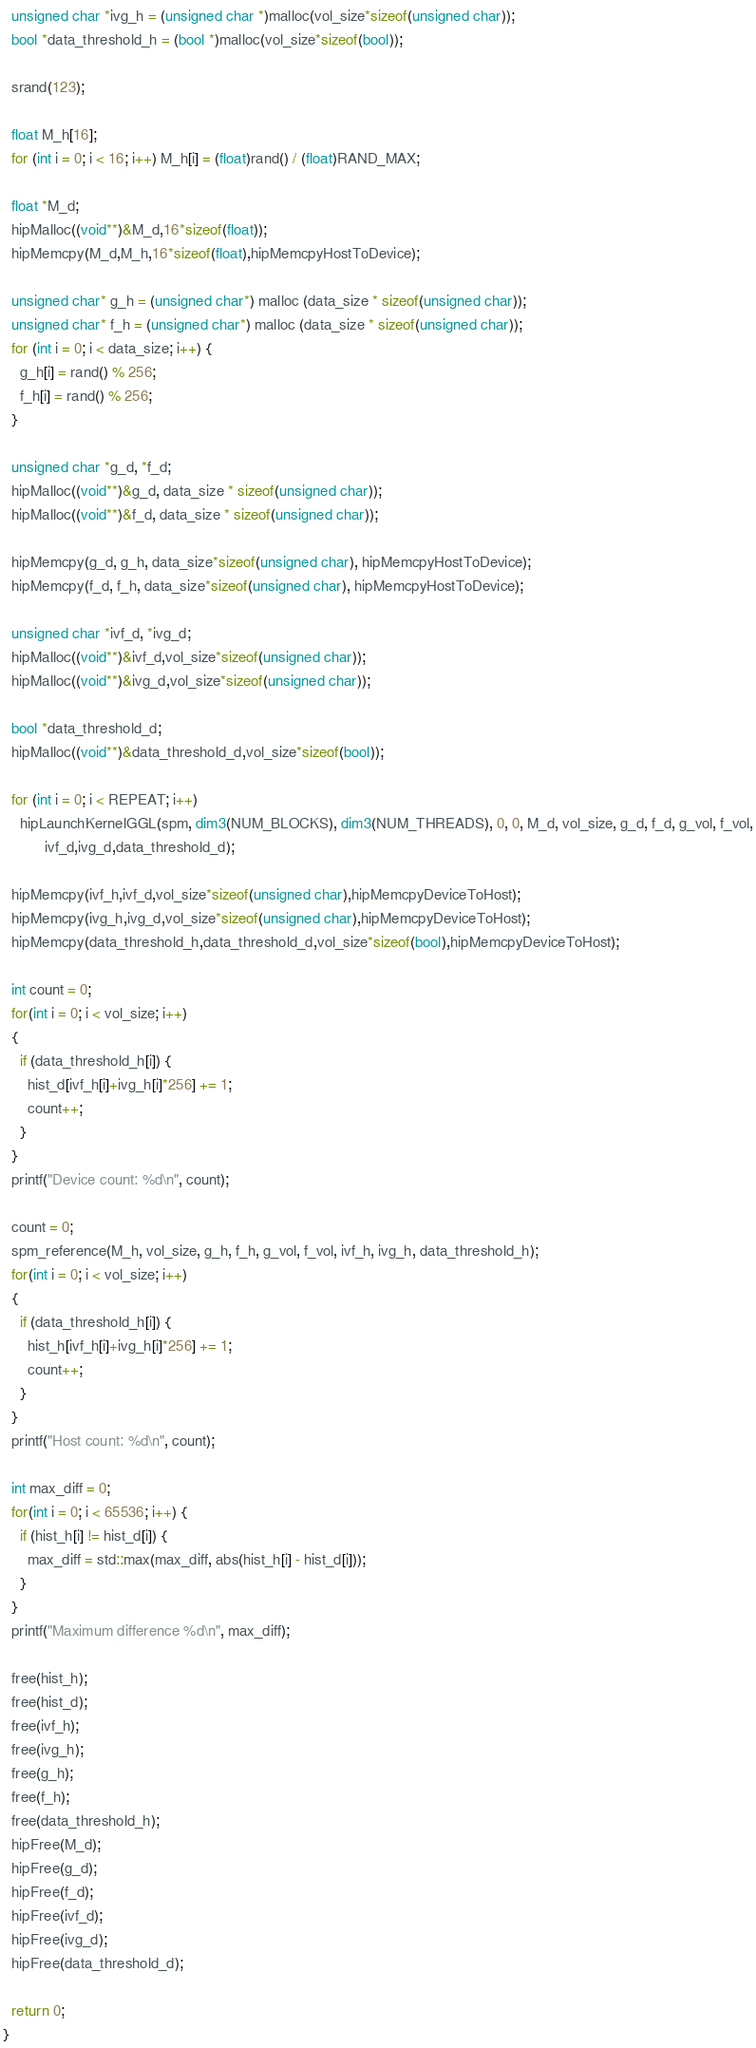<code> <loc_0><loc_0><loc_500><loc_500><_Cuda_>  unsigned char *ivg_h = (unsigned char *)malloc(vol_size*sizeof(unsigned char));
  bool *data_threshold_h = (bool *)malloc(vol_size*sizeof(bool));

  srand(123);

  float M_h[16];
  for (int i = 0; i < 16; i++) M_h[i] = (float)rand() / (float)RAND_MAX;

  float *M_d;
  hipMalloc((void**)&M_d,16*sizeof(float));
  hipMemcpy(M_d,M_h,16*sizeof(float),hipMemcpyHostToDevice);

  unsigned char* g_h = (unsigned char*) malloc (data_size * sizeof(unsigned char));
  unsigned char* f_h = (unsigned char*) malloc (data_size * sizeof(unsigned char));
  for (int i = 0; i < data_size; i++) {
    g_h[i] = rand() % 256;
    f_h[i] = rand() % 256;
  }

  unsigned char *g_d, *f_d;
  hipMalloc((void**)&g_d, data_size * sizeof(unsigned char));
  hipMalloc((void**)&f_d, data_size * sizeof(unsigned char));

  hipMemcpy(g_d, g_h, data_size*sizeof(unsigned char), hipMemcpyHostToDevice);
  hipMemcpy(f_d, f_h, data_size*sizeof(unsigned char), hipMemcpyHostToDevice);

  unsigned char *ivf_d, *ivg_d;
  hipMalloc((void**)&ivf_d,vol_size*sizeof(unsigned char));
  hipMalloc((void**)&ivg_d,vol_size*sizeof(unsigned char));

  bool *data_threshold_d;
  hipMalloc((void**)&data_threshold_d,vol_size*sizeof(bool));

  for (int i = 0; i < REPEAT; i++)
    hipLaunchKernelGGL(spm, dim3(NUM_BLOCKS), dim3(NUM_THREADS), 0, 0, M_d, vol_size, g_d, f_d, g_vol, f_vol,
		  ivf_d,ivg_d,data_threshold_d);

  hipMemcpy(ivf_h,ivf_d,vol_size*sizeof(unsigned char),hipMemcpyDeviceToHost);
  hipMemcpy(ivg_h,ivg_d,vol_size*sizeof(unsigned char),hipMemcpyDeviceToHost);
  hipMemcpy(data_threshold_h,data_threshold_d,vol_size*sizeof(bool),hipMemcpyDeviceToHost);

  int count = 0;
  for(int i = 0; i < vol_size; i++)
  {
    if (data_threshold_h[i]) {
      hist_d[ivf_h[i]+ivg_h[i]*256] += 1;    
      count++;
    }
  }
  printf("Device count: %d\n", count);

  count = 0;
  spm_reference(M_h, vol_size, g_h, f_h, g_vol, f_vol, ivf_h, ivg_h, data_threshold_h);
  for(int i = 0; i < vol_size; i++)
  {
    if (data_threshold_h[i]) {
      hist_h[ivf_h[i]+ivg_h[i]*256] += 1;    
      count++;
    }
  }
  printf("Host count: %d\n", count);

  int max_diff = 0;
  for(int i = 0; i < 65536; i++) {
    if (hist_h[i] != hist_d[i]) {
      max_diff = std::max(max_diff, abs(hist_h[i] - hist_d[i]));
    }
  }
  printf("Maximum difference %d\n", max_diff);

  free(hist_h);
  free(hist_d);
  free(ivf_h);
  free(ivg_h);
  free(g_h);
  free(f_h);
  free(data_threshold_h);
  hipFree(M_d);
  hipFree(g_d);
  hipFree(f_d);
  hipFree(ivf_d);
  hipFree(ivg_d);
  hipFree(data_threshold_d);

  return 0;
}
</code> 